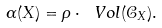<formula> <loc_0><loc_0><loc_500><loc_500>\alpha ( X ) = \rho \cdot \ V o l ( \mathcal { C } _ { X } ) .</formula> 